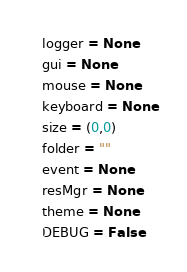Convert code to text. <code><loc_0><loc_0><loc_500><loc_500><_Python_>logger = None
gui = None
mouse = None
keyboard = None
size = (0,0)
folder = ""
event = None
resMgr = None
theme = None
DEBUG = False</code> 